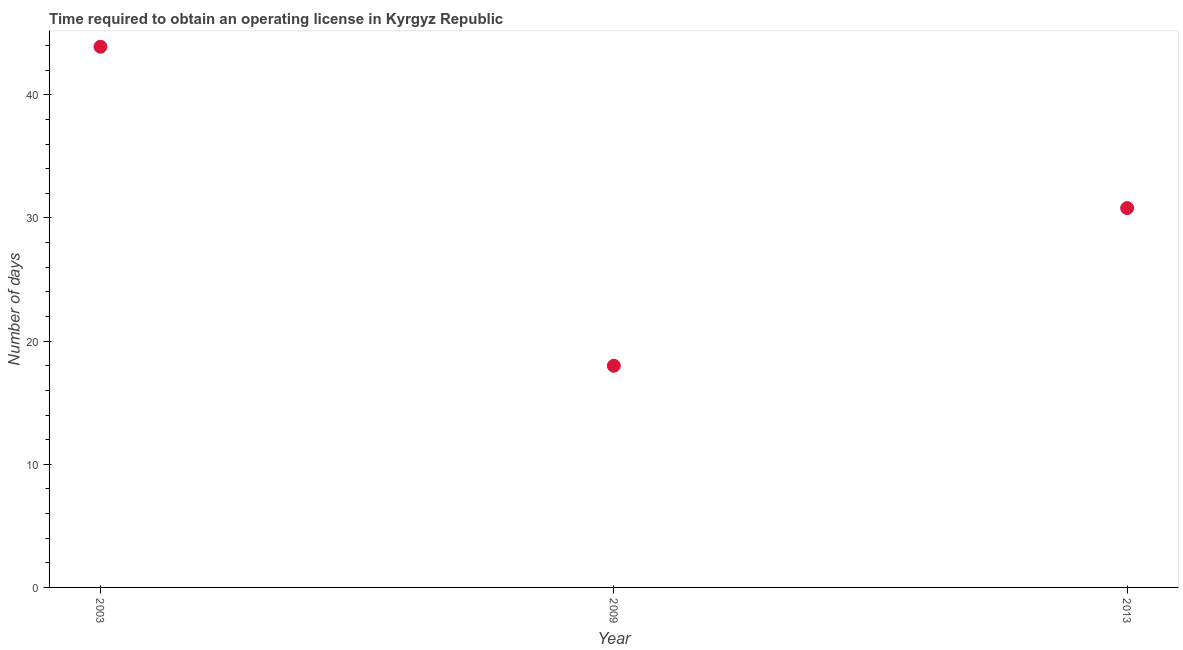What is the number of days to obtain operating license in 2003?
Make the answer very short. 43.9. Across all years, what is the maximum number of days to obtain operating license?
Your answer should be very brief. 43.9. In which year was the number of days to obtain operating license maximum?
Ensure brevity in your answer.  2003. What is the sum of the number of days to obtain operating license?
Keep it short and to the point. 92.7. What is the difference between the number of days to obtain operating license in 2009 and 2013?
Your response must be concise. -12.8. What is the average number of days to obtain operating license per year?
Give a very brief answer. 30.9. What is the median number of days to obtain operating license?
Provide a succinct answer. 30.8. Do a majority of the years between 2003 and 2009 (inclusive) have number of days to obtain operating license greater than 16 days?
Ensure brevity in your answer.  Yes. What is the ratio of the number of days to obtain operating license in 2003 to that in 2009?
Offer a very short reply. 2.44. Is the number of days to obtain operating license in 2003 less than that in 2009?
Ensure brevity in your answer.  No. What is the difference between the highest and the second highest number of days to obtain operating license?
Your answer should be very brief. 13.1. What is the difference between the highest and the lowest number of days to obtain operating license?
Offer a very short reply. 25.9. Does the number of days to obtain operating license monotonically increase over the years?
Offer a very short reply. No. How many dotlines are there?
Give a very brief answer. 1. How many years are there in the graph?
Offer a very short reply. 3. Does the graph contain grids?
Ensure brevity in your answer.  No. What is the title of the graph?
Make the answer very short. Time required to obtain an operating license in Kyrgyz Republic. What is the label or title of the Y-axis?
Ensure brevity in your answer.  Number of days. What is the Number of days in 2003?
Your answer should be very brief. 43.9. What is the Number of days in 2013?
Your response must be concise. 30.8. What is the difference between the Number of days in 2003 and 2009?
Your answer should be compact. 25.9. What is the difference between the Number of days in 2003 and 2013?
Provide a succinct answer. 13.1. What is the difference between the Number of days in 2009 and 2013?
Your answer should be compact. -12.8. What is the ratio of the Number of days in 2003 to that in 2009?
Keep it short and to the point. 2.44. What is the ratio of the Number of days in 2003 to that in 2013?
Your response must be concise. 1.43. What is the ratio of the Number of days in 2009 to that in 2013?
Your answer should be compact. 0.58. 